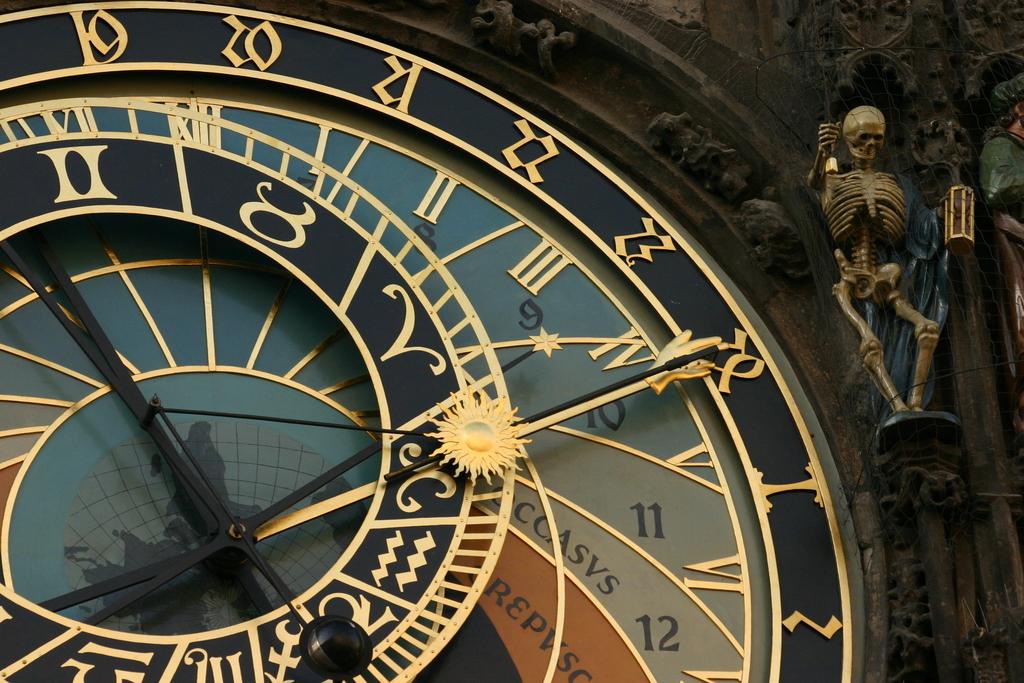What number is the hand of the clock pointing at?
Ensure brevity in your answer.  10. How many numbers are on the outer ring of this clock?
Make the answer very short. Unanswerable. 